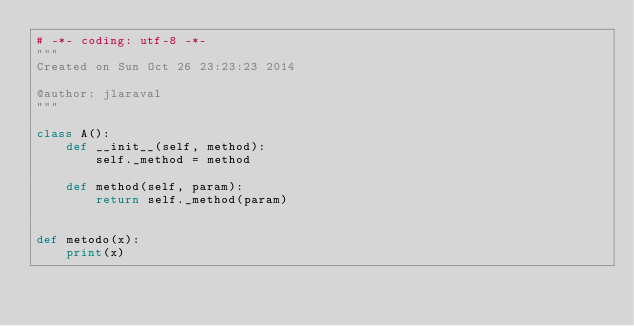Convert code to text. <code><loc_0><loc_0><loc_500><loc_500><_Python_># -*- coding: utf-8 -*-
"""
Created on Sun Oct 26 23:23:23 2014

@author: jlaraval
"""

class A():
    def __init__(self, method):
        self._method = method
        
    def method(self, param):
        return self._method(param)
        

def metodo(x):
    print(x)</code> 